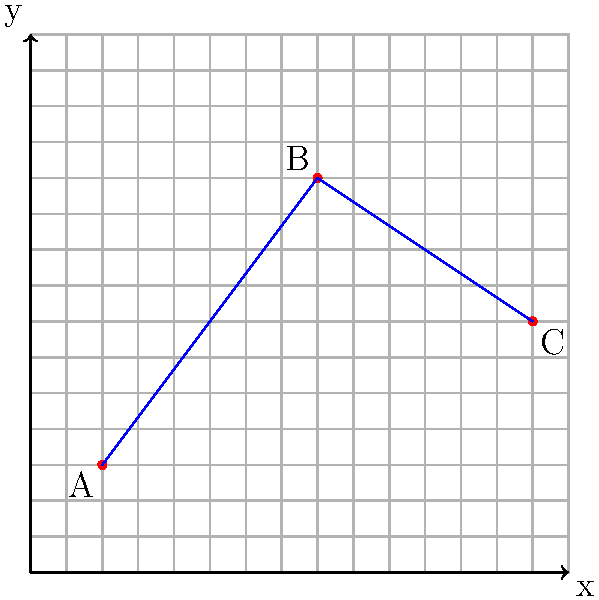A basketball player performs an agility drill on a coordinate grid where each unit represents 1 meter. The player starts at point A(2,3), runs to point B(8,11), and then finishes at point C(14,7). Calculate the total distance traveled by the player during this drill to the nearest meter. To find the total distance traveled, we need to calculate the distance between points A and B, and then between B and C, using the distance formula:

Distance = $\sqrt{(x_2-x_1)^2 + (y_2-y_1)^2}$

1. Distance from A to B:
   $AB = \sqrt{(8-2)^2 + (11-3)^2}$
   $AB = \sqrt{6^2 + 8^2}$
   $AB = \sqrt{36 + 64} = \sqrt{100} = 10$ meters

2. Distance from B to C:
   $BC = \sqrt{(14-8)^2 + (7-11)^2}$
   $BC = \sqrt{6^2 + (-4)^2}$
   $BC = \sqrt{36 + 16} = \sqrt{52} \approx 7.21$ meters

3. Total distance:
   Total = AB + BC = 10 + 7.21 = 17.21 meters

4. Rounding to the nearest meter:
   17.21 rounds to 17 meters
Answer: 17 meters 